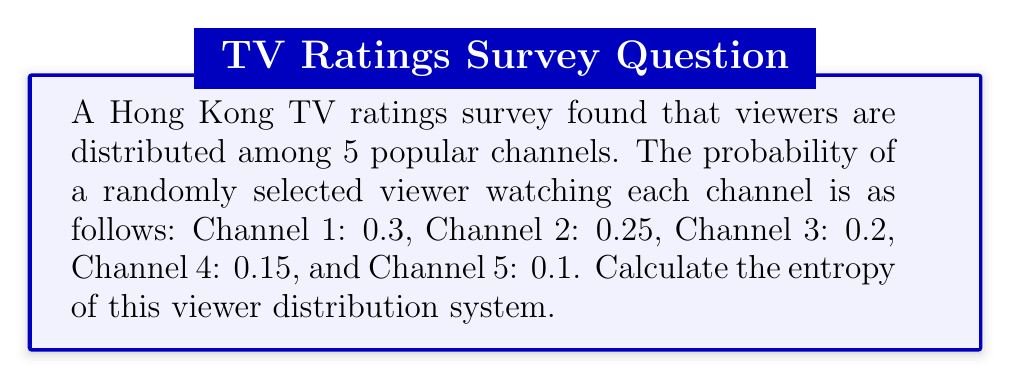Solve this math problem. To solve this problem, we'll use the formula for entropy in statistical mechanics:

$$S = -k_B \sum_{i=1}^{n} p_i \ln(p_i)$$

Where:
$S$ is the entropy
$k_B$ is Boltzmann's constant (which we'll take as 1 for simplicity)
$p_i$ is the probability of the system being in the $i$-th state
$n$ is the number of possible states (in this case, 5 channels)

Let's calculate each term:

1. Channel 1: $-0.3 \ln(0.3) = 0.3611$
2. Channel 2: $-0.25 \ln(0.25) = 0.3466$
3. Channel 3: $-0.2 \ln(0.2) = 0.3219$
4. Channel 4: $-0.15 \ln(0.15) = 0.2875$
5. Channel 5: $-0.1 \ln(0.1) = 0.2303$

Now, we sum these values:

$$S = 0.3611 + 0.3466 + 0.3219 + 0.2875 + 0.2303 = 1.5474$$

Therefore, the entropy of the viewer distribution system is approximately 1.5474.
Answer: $1.5474$ 